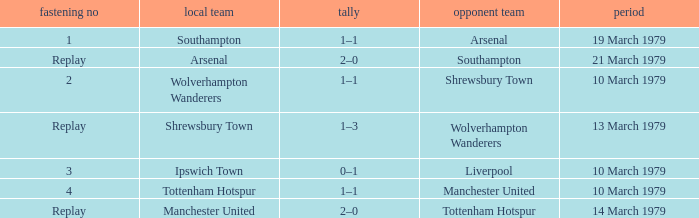What was the score of the tie that had Tottenham Hotspur as the home team? 1–1. 